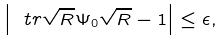<formula> <loc_0><loc_0><loc_500><loc_500>\left | \ t r \sqrt { R } \Psi _ { 0 } \sqrt { R } - 1 \right | \leq \epsilon ,</formula> 